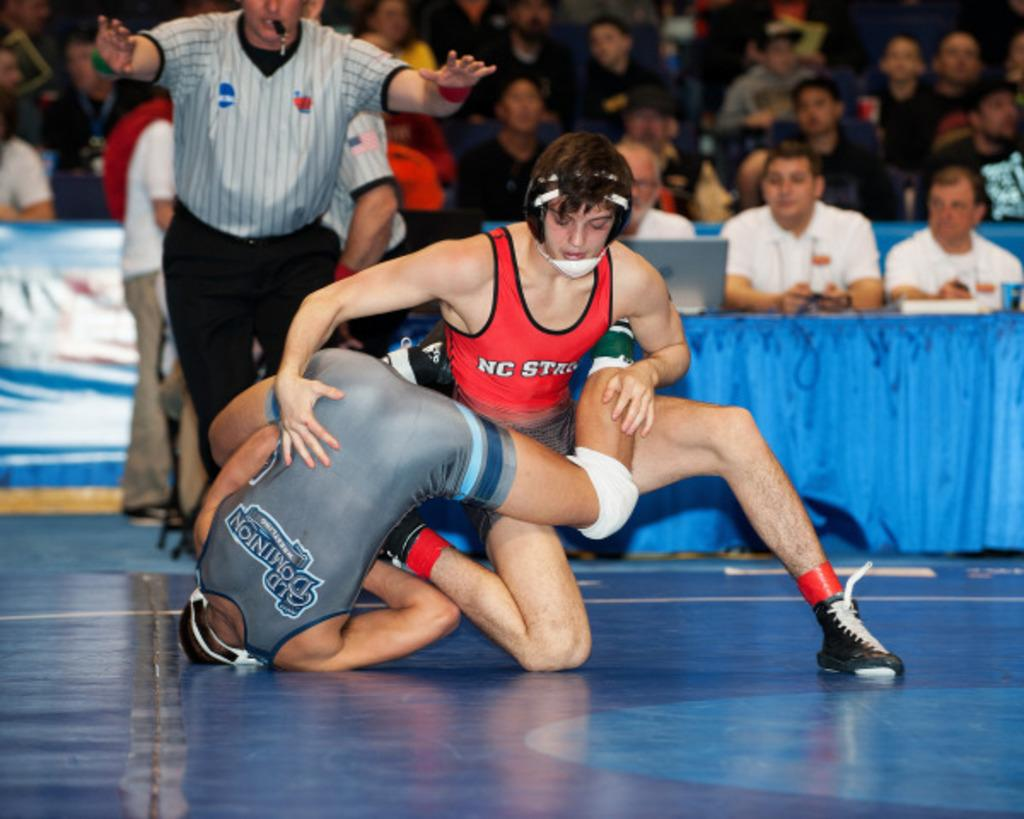Provide a one-sentence caption for the provided image. Two collegiate wrestlers, one from NC State wearing red singlet, are wrestling each other on the blue mat. 